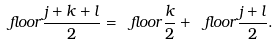<formula> <loc_0><loc_0><loc_500><loc_500>\ f l o o r { \frac { j + k + l } { 2 } } = \ f l o o r { \frac { k } { 2 } } + \ f l o o r { \frac { j + l } { 2 } } .</formula> 